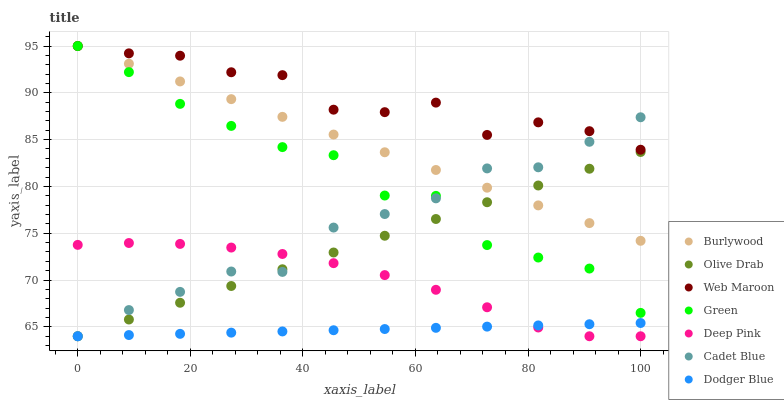Does Dodger Blue have the minimum area under the curve?
Answer yes or no. Yes. Does Web Maroon have the maximum area under the curve?
Answer yes or no. Yes. Does Burlywood have the minimum area under the curve?
Answer yes or no. No. Does Burlywood have the maximum area under the curve?
Answer yes or no. No. Is Dodger Blue the smoothest?
Answer yes or no. Yes. Is Web Maroon the roughest?
Answer yes or no. Yes. Is Burlywood the smoothest?
Answer yes or no. No. Is Burlywood the roughest?
Answer yes or no. No. Does Cadet Blue have the lowest value?
Answer yes or no. Yes. Does Burlywood have the lowest value?
Answer yes or no. No. Does Green have the highest value?
Answer yes or no. Yes. Does Deep Pink have the highest value?
Answer yes or no. No. Is Deep Pink less than Green?
Answer yes or no. Yes. Is Green greater than Dodger Blue?
Answer yes or no. Yes. Does Cadet Blue intersect Green?
Answer yes or no. Yes. Is Cadet Blue less than Green?
Answer yes or no. No. Is Cadet Blue greater than Green?
Answer yes or no. No. Does Deep Pink intersect Green?
Answer yes or no. No. 